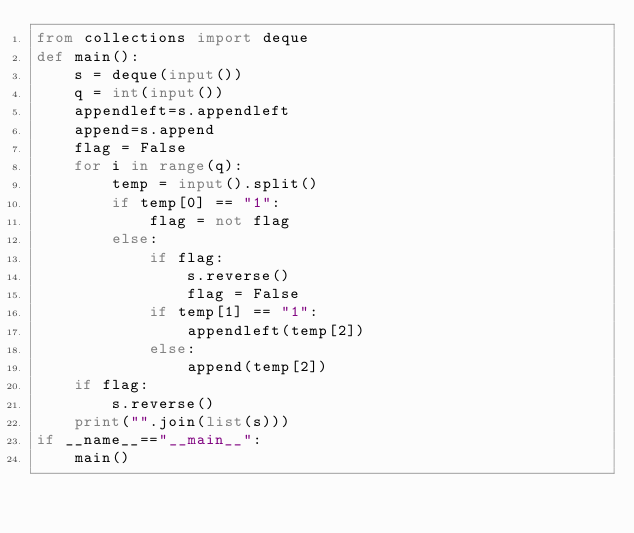<code> <loc_0><loc_0><loc_500><loc_500><_Python_>from collections import deque
def main():
    s = deque(input())
    q = int(input())
    appendleft=s.appendleft
    append=s.append
    flag = False
    for i in range(q):
        temp = input().split()
        if temp[0] == "1":
            flag = not flag
        else:
            if flag:
                s.reverse()
                flag = False
            if temp[1] == "1":
                appendleft(temp[2])
            else:
                append(temp[2])
    if flag:
        s.reverse()
    print("".join(list(s)))
if __name__=="__main__":
    main()
</code> 